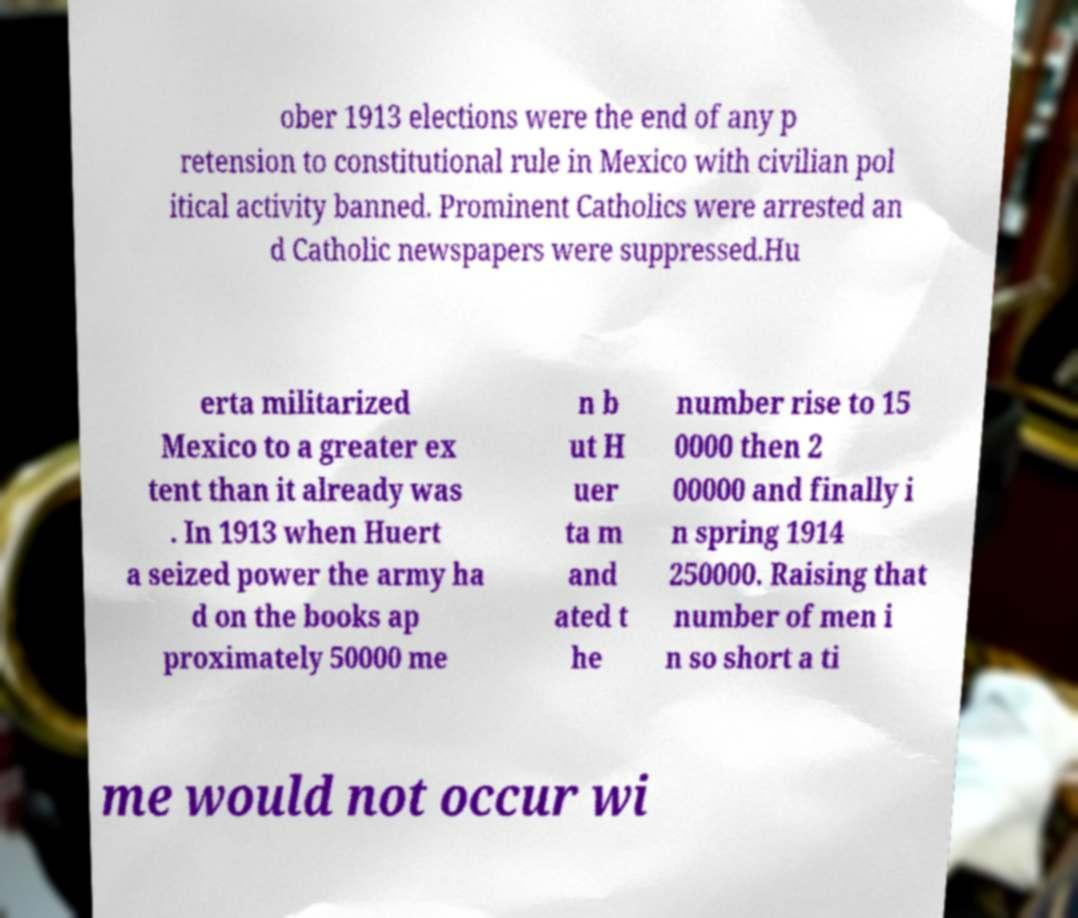Please identify and transcribe the text found in this image. ober 1913 elections were the end of any p retension to constitutional rule in Mexico with civilian pol itical activity banned. Prominent Catholics were arrested an d Catholic newspapers were suppressed.Hu erta militarized Mexico to a greater ex tent than it already was . In 1913 when Huert a seized power the army ha d on the books ap proximately 50000 me n b ut H uer ta m and ated t he number rise to 15 0000 then 2 00000 and finally i n spring 1914 250000. Raising that number of men i n so short a ti me would not occur wi 